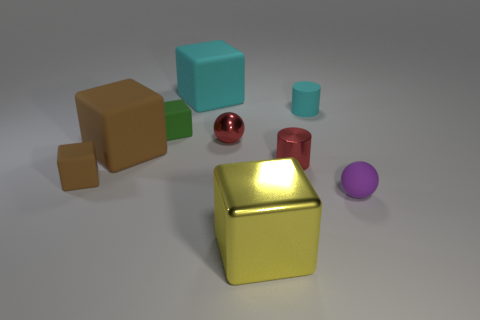There is a thing that is in front of the small purple sphere; is it the same color as the small matte sphere?
Provide a succinct answer. No. What is the material of the object that is behind the tiny green cube and right of the tiny red metallic sphere?
Offer a very short reply. Rubber. Is the number of large metallic cubes greater than the number of small cyan metal balls?
Your answer should be compact. Yes. There is a cylinder left of the cyan matte object in front of the cyan matte object on the left side of the yellow block; what color is it?
Your answer should be compact. Red. Are the block to the right of the large cyan block and the red cylinder made of the same material?
Your response must be concise. Yes. Is there a object of the same color as the shiny block?
Offer a terse response. No. Are there any small rubber cylinders?
Your answer should be compact. Yes. Does the cyan thing that is on the right side of the yellow thing have the same size as the large cyan block?
Your answer should be very brief. No. Are there fewer red cylinders than large yellow spheres?
Ensure brevity in your answer.  No. What shape is the metal object that is behind the big rubber cube that is in front of the small rubber block behind the small brown matte thing?
Keep it short and to the point. Sphere. 